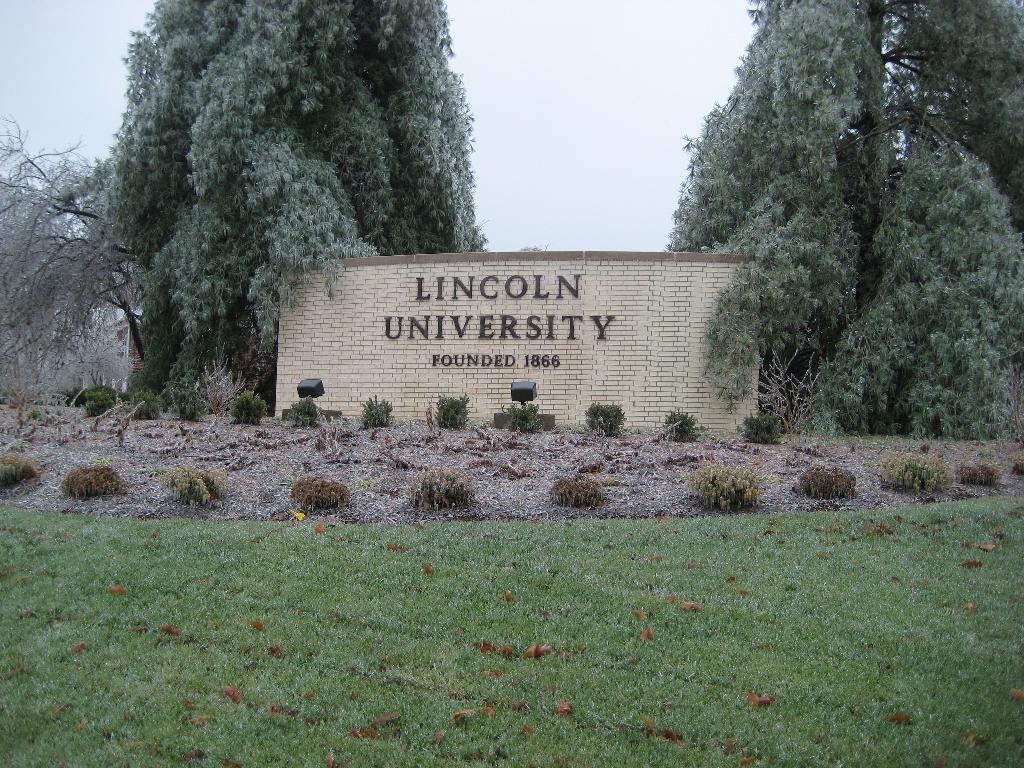Please provide a concise description of this image. In this image there is grass, plants, focus lights, trees, a wall with numbers and a university name on it , and in the background there is sky. 